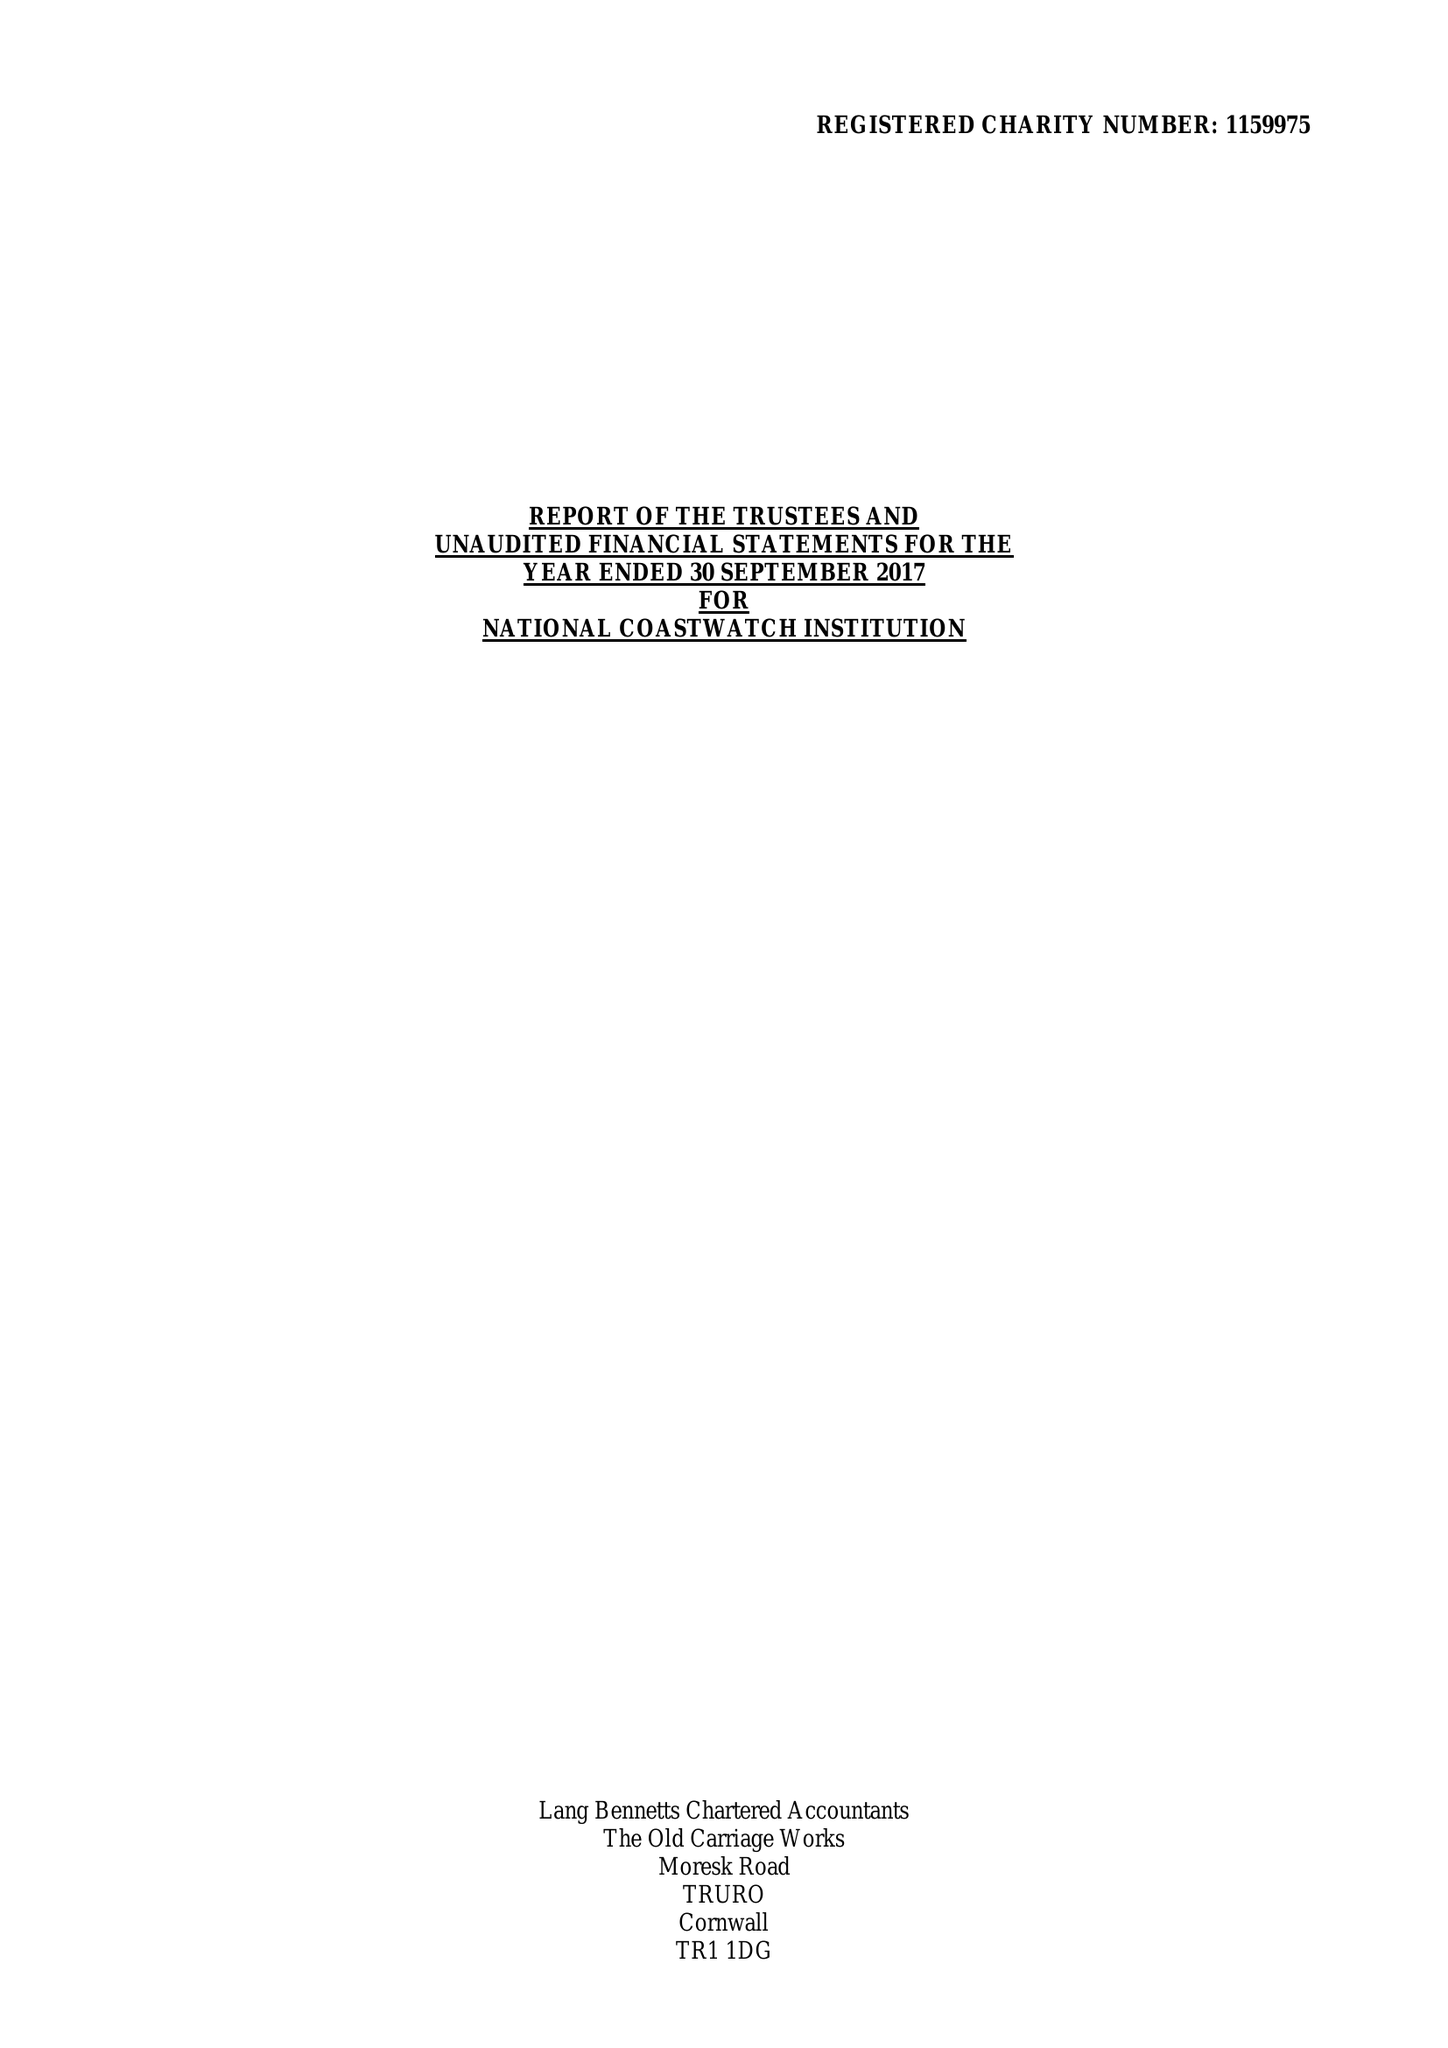What is the value for the charity_name?
Answer the question using a single word or phrase. National Coastwatch Institution 